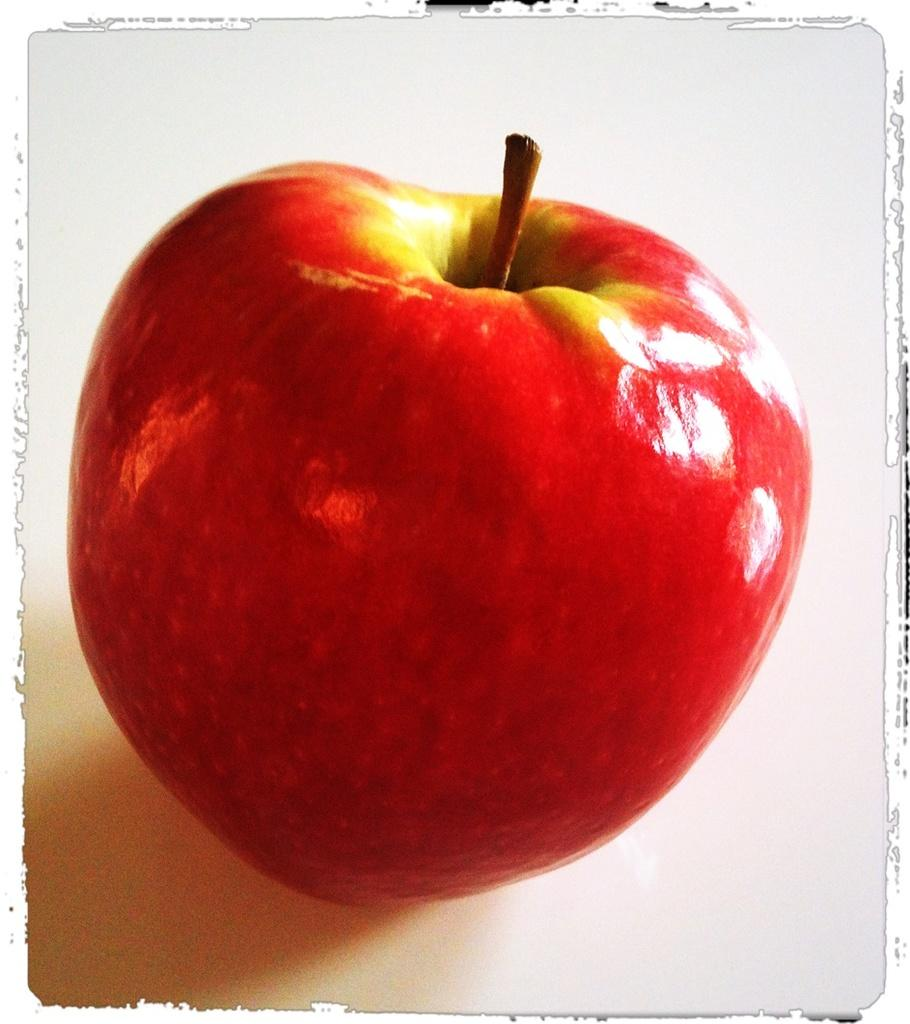What object is on the floor in the image? There is an apple on the floor in the image. What type of artwork is the image? The image appears to be a painting. What type of creature is depicted in the painting, thinking about the apple? There is no creature depicted in the painting, and the painting does not show any thoughts or actions related to the apple. 